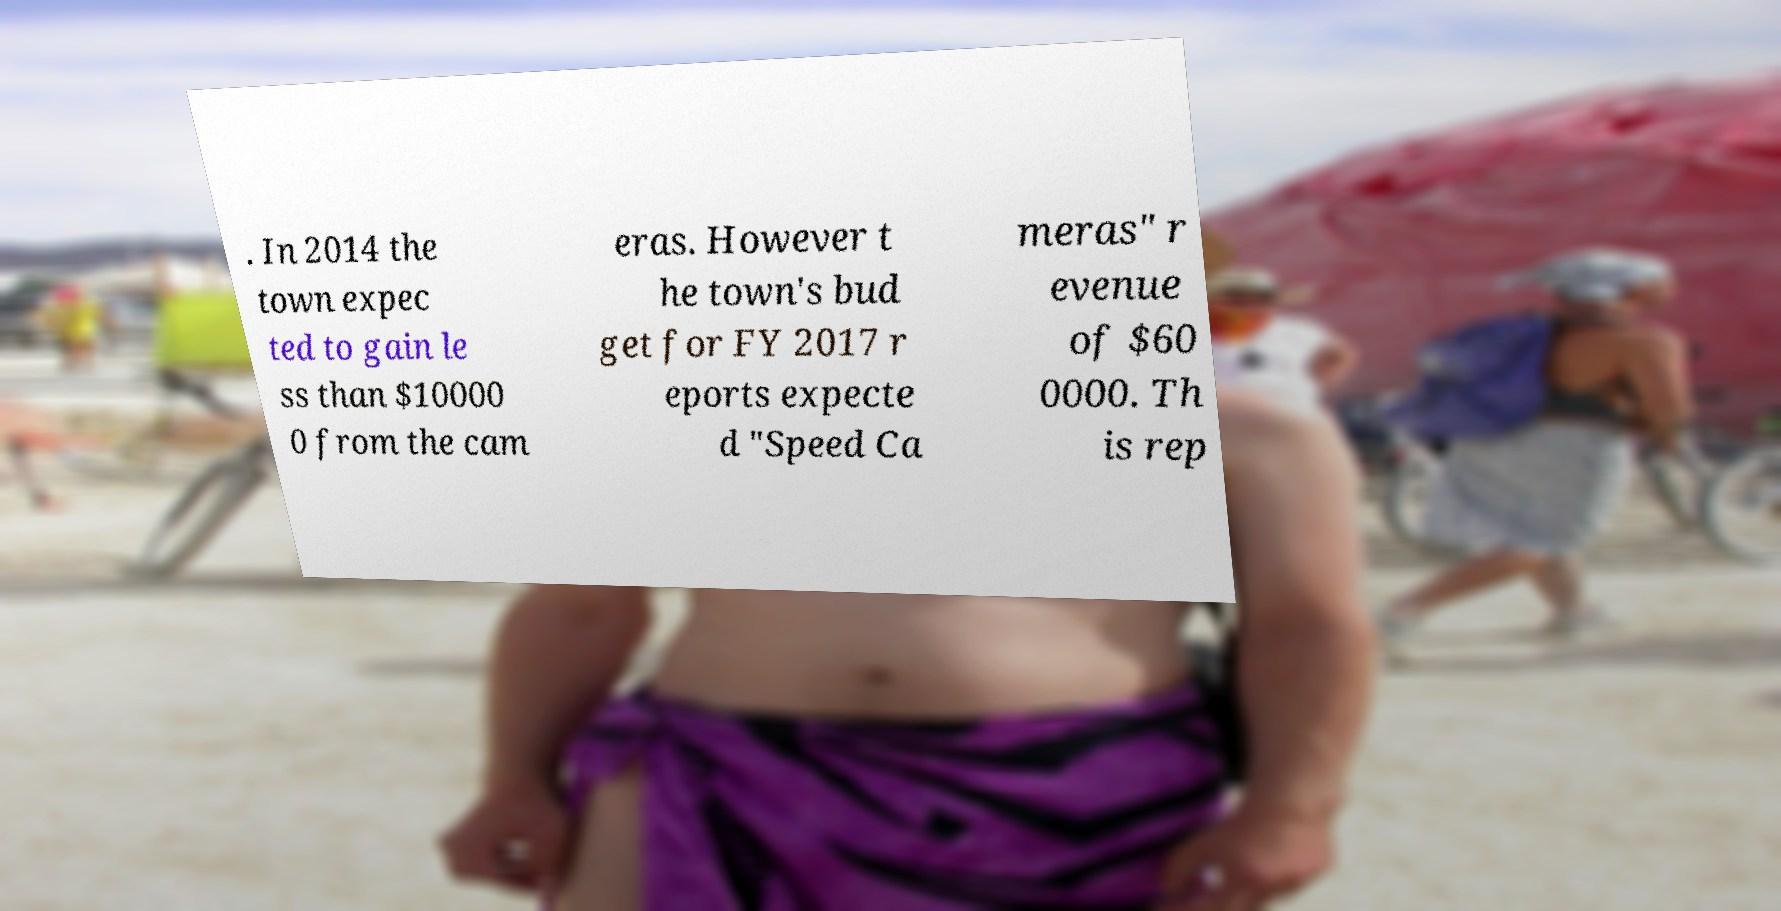For documentation purposes, I need the text within this image transcribed. Could you provide that? . In 2014 the town expec ted to gain le ss than $10000 0 from the cam eras. However t he town's bud get for FY 2017 r eports expecte d "Speed Ca meras" r evenue of $60 0000. Th is rep 